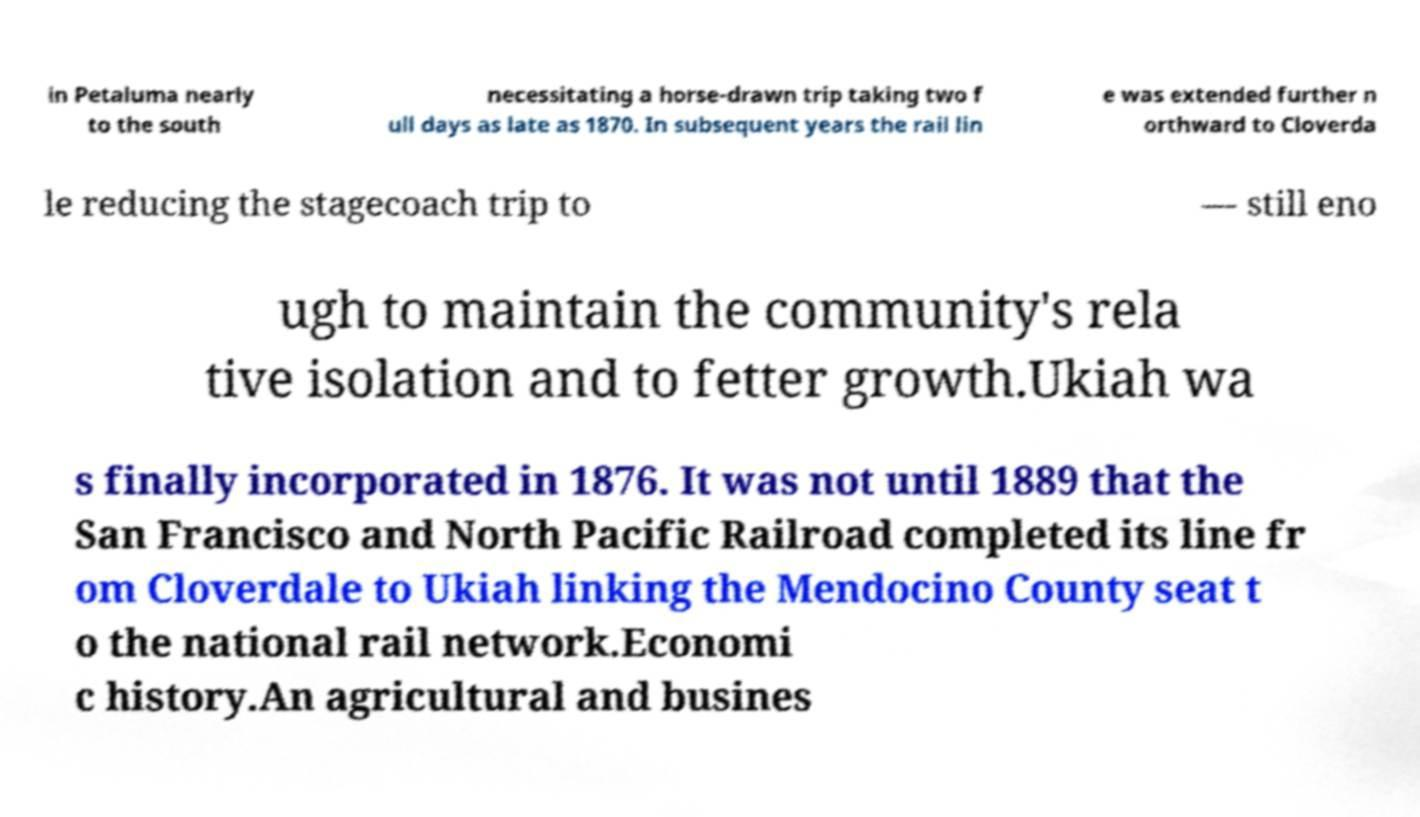Can you accurately transcribe the text from the provided image for me? in Petaluma nearly to the south necessitating a horse-drawn trip taking two f ull days as late as 1870. In subsequent years the rail lin e was extended further n orthward to Cloverda le reducing the stagecoach trip to — still eno ugh to maintain the community's rela tive isolation and to fetter growth.Ukiah wa s finally incorporated in 1876. It was not until 1889 that the San Francisco and North Pacific Railroad completed its line fr om Cloverdale to Ukiah linking the Mendocino County seat t o the national rail network.Economi c history.An agricultural and busines 